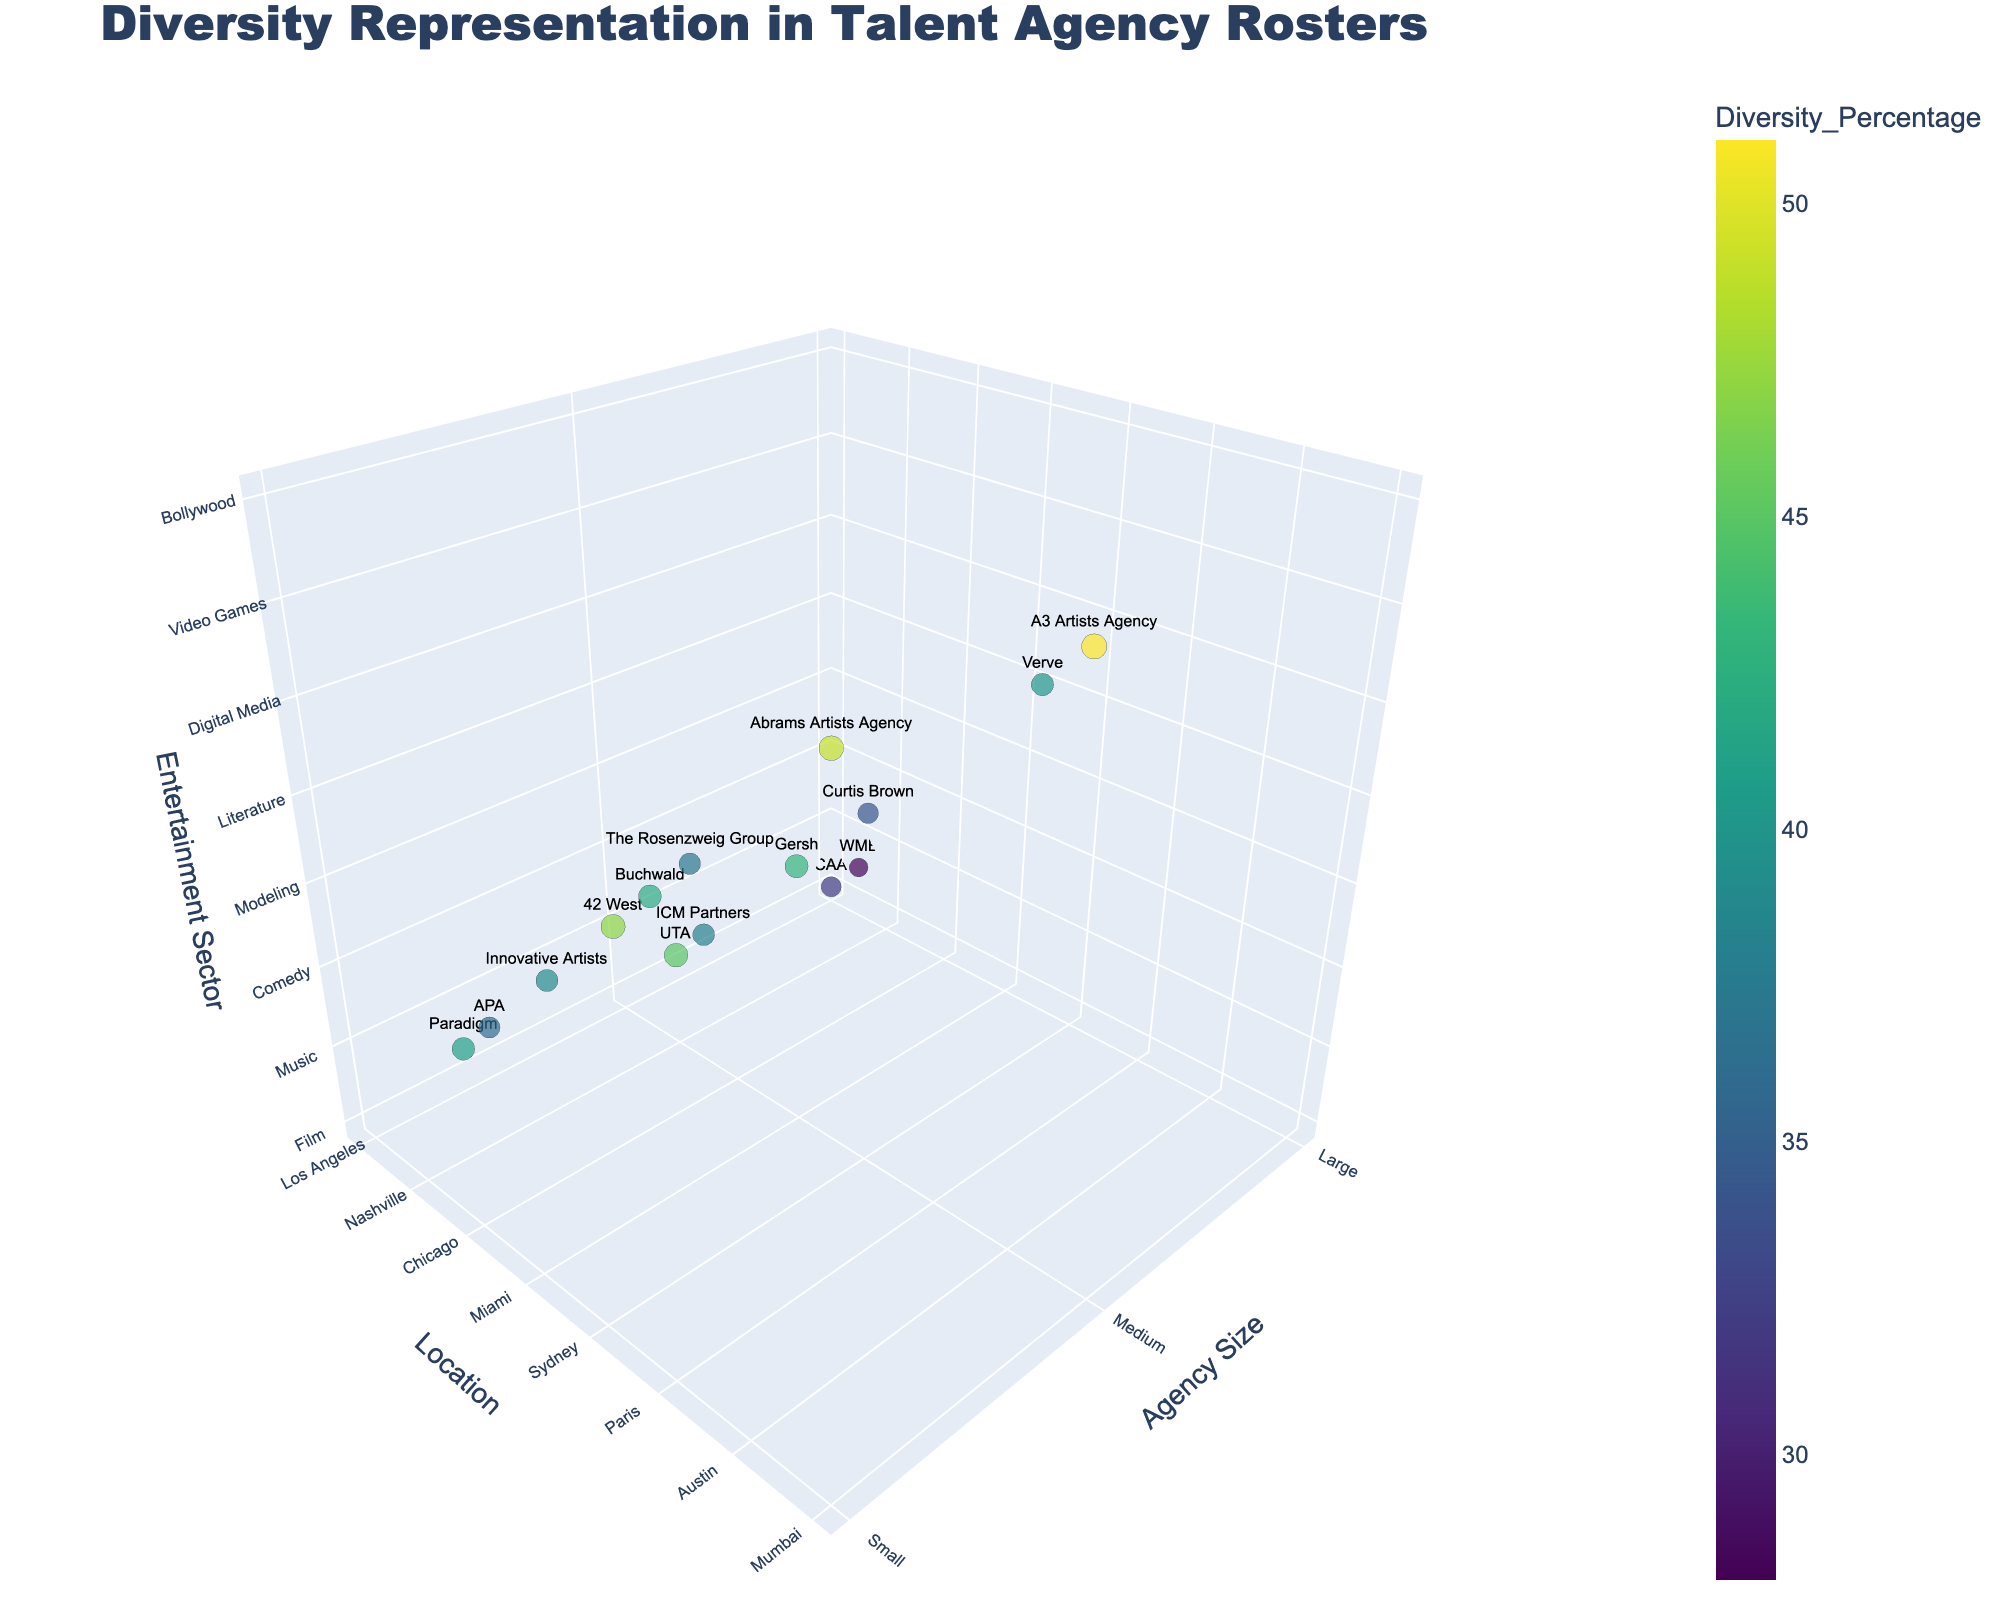What is the title of the figure? The title is displayed prominently at the top of the figure in a larger font size, clearly stating the subject of the plot.
Answer: Diversity Representation in Talent Agency Rosters How many different agency sizes are represented in the plot? Observing the axis labeled "Agency Size," you'll see three different tick marks, each representing a unique agency size category.
Answer: 3 Which agency has the highest diversity percentage? By observing the size of the markers in the plot and hovering over the data points, the A3 Artists Agency in Seoul has the largest marker, indicating the highest diversity percentage.
Answer: A3 Artists Agency Which location has the highest number of small agencies? By examining the plot and counting the markers labeled with agency names in each location, you can determine that Paris hosts the most small agencies.
Answer: Paris Which entertainment sector has the largest range of diversity percentages? By looking at the spread of the markers along the "Entertainment Sector" axis and their varying sizes, you notice that the Film sector contains a large range of diversity percentages.
Answer: Film Compare the diversity percentage between large and small agencies in Los Angeles. Hovering over the data points and comparing the size/color of markers for large and small agencies in Los Angeles, you find that there’s only one large agency (CAA with 32%). Small agencies are not represented in Los Angeles.
Answer: CAA: 32% What's the average diversity percentage of medium-sized agencies? Summing the diversity percentages of the medium-sized agencies (45+38+43+34+40+51) and dividing by the total number of medium-sized agencies (6). 45+38+43+34+40+51 = 251. 251/6 = 41.83.
Answer: 41.83 Which agency in a non-U.S. location has the highest diversity percentage? Observing the markers and their information tags for agencies outside the U.S. and comparing their sizes, you identify that Abrams Artists Agency in Mumbai has the highest diversity percentage outside the U.S.
Answer: Abrams Artists Agency 